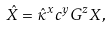<formula> <loc_0><loc_0><loc_500><loc_500>\hat { X } = \hat { \kappa } ^ { x } c ^ { y } G ^ { z } X ,</formula> 